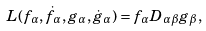Convert formula to latex. <formula><loc_0><loc_0><loc_500><loc_500>L ( f _ { \alpha } , \dot { f } _ { \alpha } , g _ { \alpha } , \dot { g } _ { \alpha } ) = f _ { \alpha } D _ { \alpha \beta } g _ { \beta } ,</formula> 